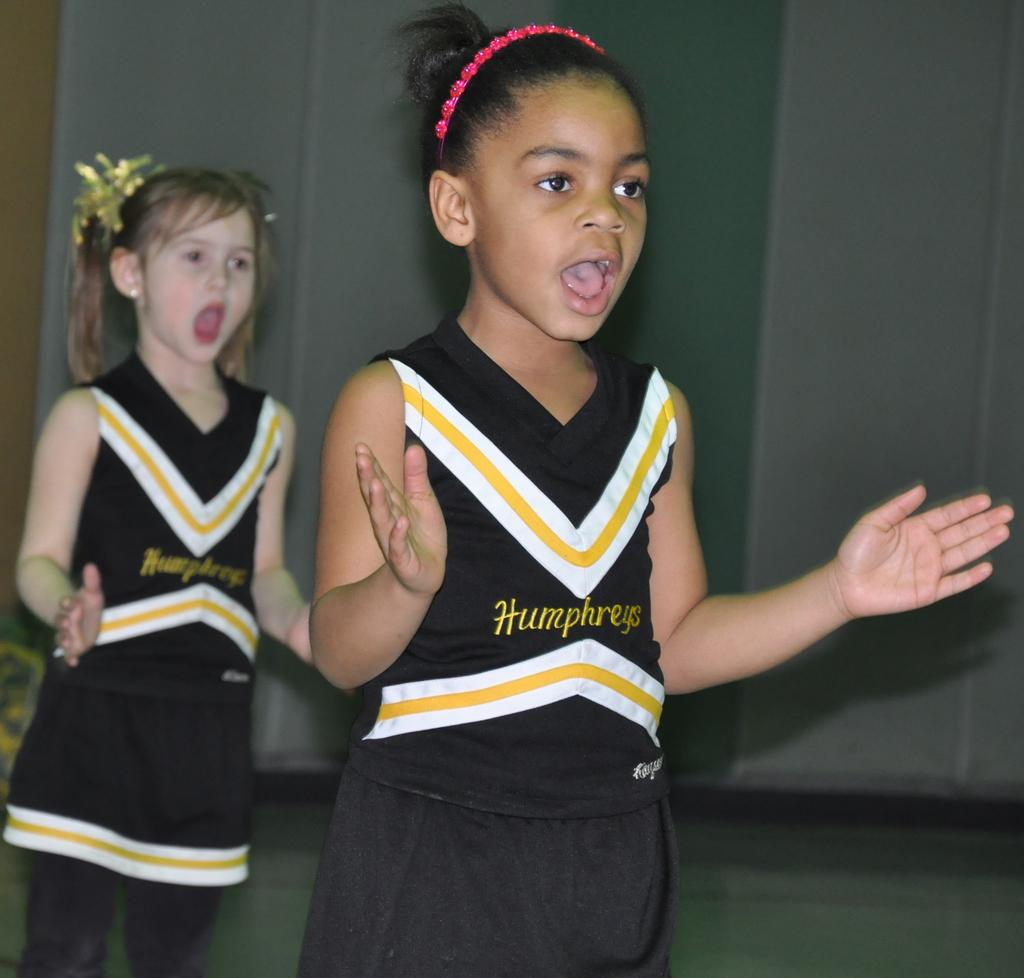<image>
Summarize the visual content of the image. Two small girls are cheering in black, white, and yellow cheerleader uniforms for Humphreys. 